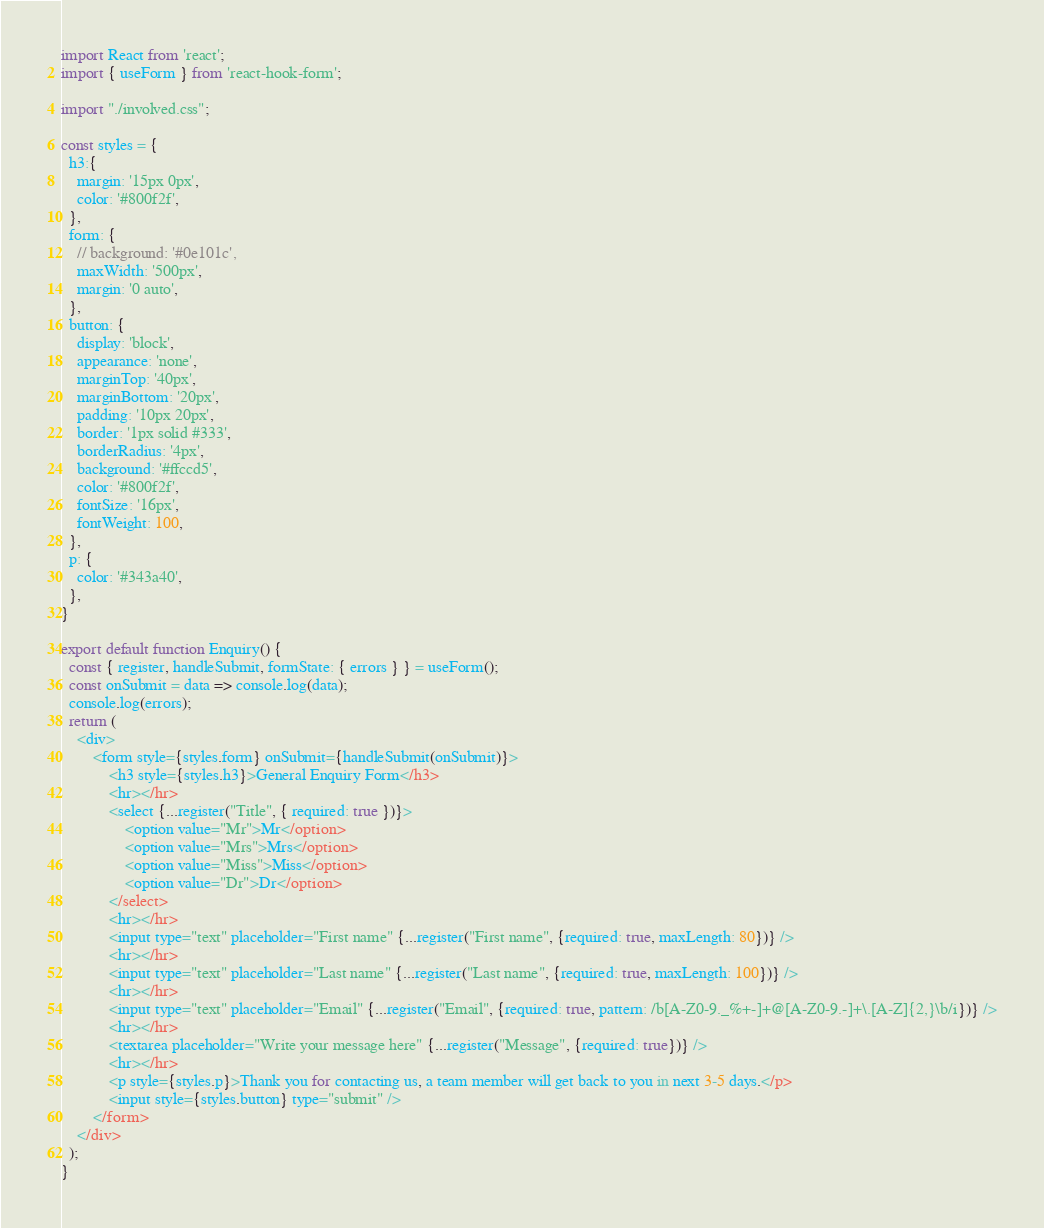<code> <loc_0><loc_0><loc_500><loc_500><_JavaScript_>import React from 'react';
import { useForm } from 'react-hook-form';

import "./involved.css";

const styles = {
  h3:{
    margin: '15px 0px',
    color: '#800f2f',
  },
  form: {
    // background: '#0e101c',
    maxWidth: '500px',
    margin: '0 auto',
  },
  button: {
    display: 'block',
    appearance: 'none',
    marginTop: '40px',
    marginBottom: '20px',
    padding: '10px 20px',
    border: '1px solid #333',
    borderRadius: '4px',
    background: '#ffccd5',
    color: '#800f2f',
    fontSize: '16px',
    fontWeight: 100,
  },
  p: {
    color: '#343a40',
  },
}

export default function Enquiry() {
  const { register, handleSubmit, formState: { errors } } = useForm();
  const onSubmit = data => console.log(data);
  console.log(errors);
  return (
    <div>
        <form style={styles.form} onSubmit={handleSubmit(onSubmit)}>
            <h3 style={styles.h3}>General Enquiry Form</h3>
            <hr></hr>
            <select {...register("Title", { required: true })}>
                <option value="Mr">Mr</option>
                <option value="Mrs">Mrs</option>
                <option value="Miss">Miss</option>
                <option value="Dr">Dr</option>
            </select>
            <hr></hr>
            <input type="text" placeholder="First name" {...register("First name", {required: true, maxLength: 80})} />
            <hr></hr>
            <input type="text" placeholder="Last name" {...register("Last name", {required: true, maxLength: 100})} />
            <hr></hr>
            <input type="text" placeholder="Email" {...register("Email", {required: true, pattern: /b[A-Z0-9._%+-]+@[A-Z0-9.-]+\.[A-Z]{2,}\b/i})} />
            <hr></hr>
            <textarea placeholder="Write your message here" {...register("Message", {required: true})} />
            <hr></hr>
            <p style={styles.p}>Thank you for contacting us, a team member will get back to you in next 3-5 days.</p>
            <input style={styles.button} type="submit" />
        </form>
    </div>
  );
}</code> 